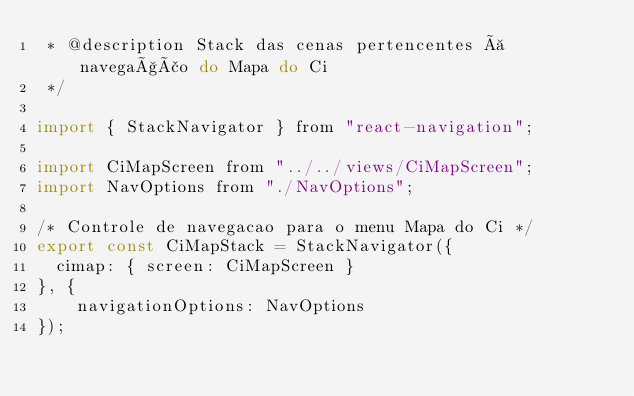Convert code to text. <code><loc_0><loc_0><loc_500><loc_500><_JavaScript_> * @description Stack das cenas pertencentes à navegação do Mapa do Ci
 */

import { StackNavigator } from "react-navigation";

import CiMapScreen from "../../views/CiMapScreen";
import NavOptions from "./NavOptions";

/* Controle de navegacao para o menu Mapa do Ci */
export const CiMapStack = StackNavigator({
  cimap: { screen: CiMapScreen }
}, {
    navigationOptions: NavOptions
});</code> 